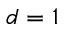<formula> <loc_0><loc_0><loc_500><loc_500>d = 1</formula> 